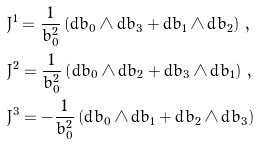<formula> <loc_0><loc_0><loc_500><loc_500>& J ^ { 1 } = \frac { 1 } { b _ { 0 } ^ { 2 } } \left ( \text {d} b _ { 0 } \wedge \text {d} b _ { 3 } + \text {d} b _ { 1 } \wedge \text {d} b _ { 2 } \right ) \, , \\ & J ^ { 2 } = \frac { 1 } { b _ { 0 } ^ { 2 } } \left ( \text {d} b _ { 0 } \wedge \text {d} b _ { 2 } + \text {d} b _ { 3 } \wedge \text {d} b _ { 1 } \right ) \, , \\ & J ^ { 3 } = - \frac { 1 } { b _ { 0 } ^ { 2 } } \left ( \text {d} b _ { 0 } \wedge \text {d} b _ { 1 } + \text {d} b _ { 2 } \wedge \text {d} b _ { 3 } \right )</formula> 